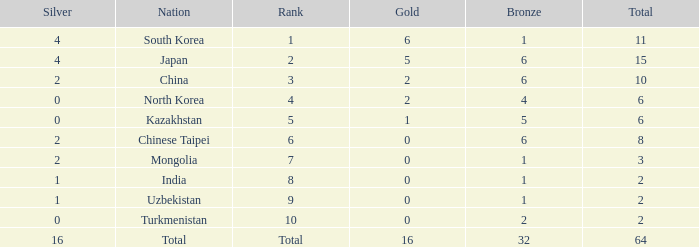What's the biggest Bronze that has less than 0 Silvers? None. 